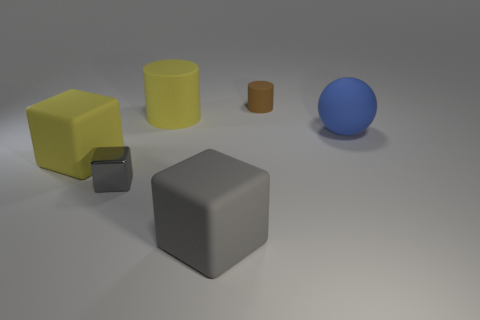Subtract all big blocks. How many blocks are left? 1 Subtract 1 blocks. How many blocks are left? 2 Add 4 large gray blocks. How many objects exist? 10 Subtract all cylinders. How many objects are left? 4 Subtract 0 purple spheres. How many objects are left? 6 Subtract all blue spheres. Subtract all gray cubes. How many objects are left? 3 Add 6 big yellow matte cubes. How many big yellow matte cubes are left? 7 Add 3 brown cylinders. How many brown cylinders exist? 4 